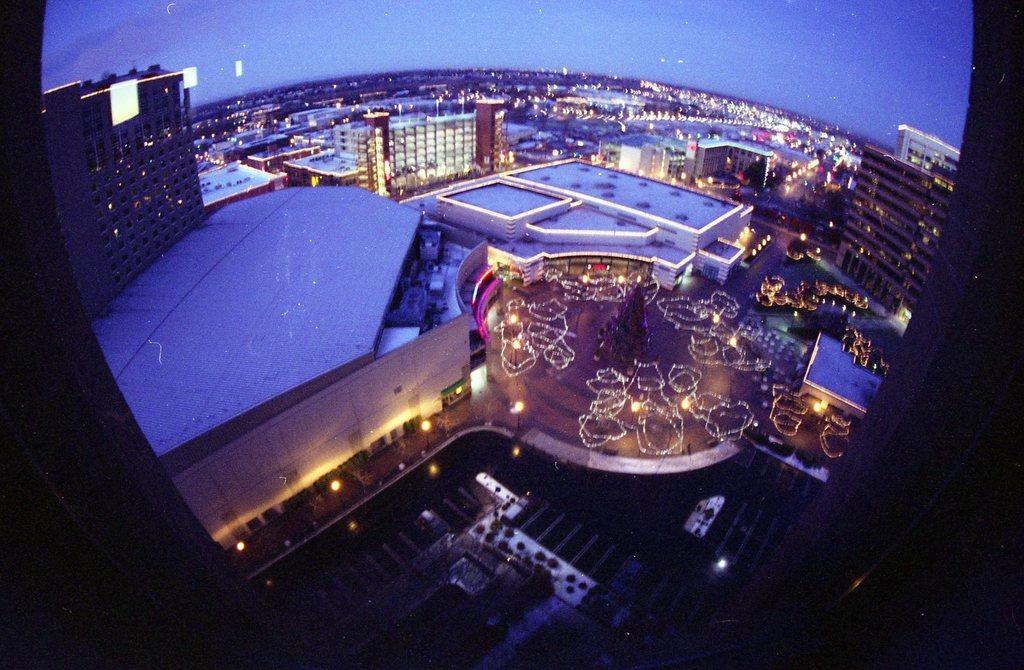What is one of the main objects in the picture? There is a mirror in the picture. What can be seen in the background of the picture? Buildings are visible in the picture. What type of illumination is present in the picture? There are lights in the picture. Can you describe any other objects in the picture? There are some objects in the picture. What is the central focus of the picture? There is a tree in the center of the picture. What day of the week is the maid's mother mentioned on the calendar in the picture? There is no maid, mother, or calendar present in the picture. 